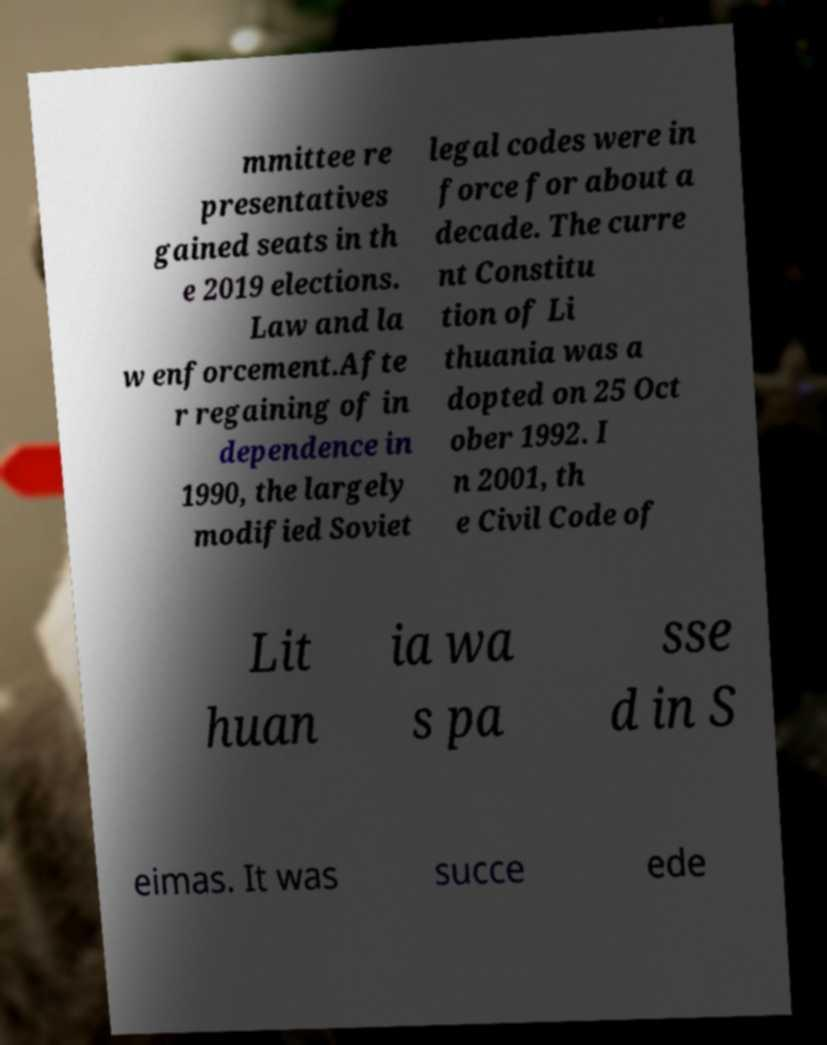Please read and relay the text visible in this image. What does it say? mmittee re presentatives gained seats in th e 2019 elections. Law and la w enforcement.Afte r regaining of in dependence in 1990, the largely modified Soviet legal codes were in force for about a decade. The curre nt Constitu tion of Li thuania was a dopted on 25 Oct ober 1992. I n 2001, th e Civil Code of Lit huan ia wa s pa sse d in S eimas. It was succe ede 